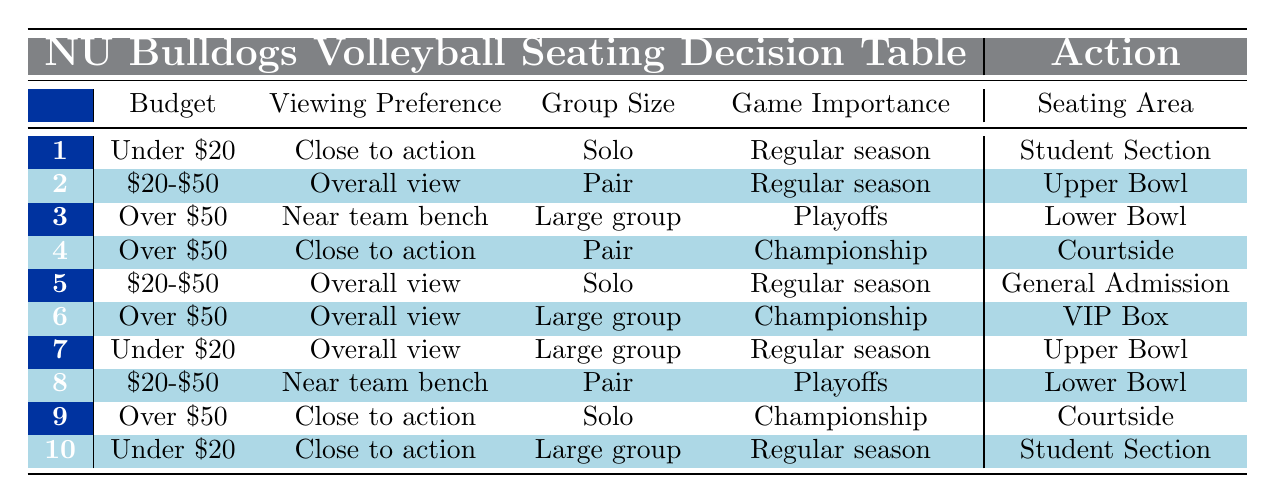What seating area is suggested for someone on a budget under $20 who prefers sitting close to the action for a regular season game? According to the table, for the conditions "Under $20," "Close to action," and "Regular season," the seating area suggested is "Student Section."
Answer: Student Section What is the recommended seating area if someone has a budget of $20 to $50, enjoys an overall view, is attending with a pair, and is going to a regular season game? The table states that for the conditions "$20-$50," "Overall view," "Pair," and "Regular season," the recommended seating area is "Upper Bowl."
Answer: Upper Bowl Is the "VIP Box" option available for large groups during championship games? Based on the table, the "VIP Box" option is available only under the conditions of "Over $50," "Overall view," "Large group," and "Championship." Therefore, yes, it is available.
Answer: Yes What seating area is recommended for a solo attendee with a budget of over $50 who wants to sit close to the action during a championship game? For "Over $50," "Close to action," "Solo," and "Championship," the table indicates the recommended seating area is "Courtside."
Answer: Courtside Can you identify the number of seating options available for individuals or pairs with a budget of $20 to $50 during playoff games? The table provides two relevant rules for this condition: one for "Overall view" which suggests "Upper Bowl" for a pair, and one for "Near team bench" which suggests "Lower Bowl" for a pair as well. This totals to three options that fit the requirement.
Answer: 2 If a large group wants to watch a regular season game and is on a budget of under $20, which seating area is available? For the conditions of "Under $20," "Overall view," "Large group," and "Regular season," the seating area listed in the table is "Upper Bowl."
Answer: Upper Bowl For an individual attending a playoff game and willing to spend over $50, where should they sit if they prefer an overall view? The table indicates that for "Over $50," "Overall view," "Solo," and "Playoffs," the suggested seating area is "General Admission."
Answer: General Admission What options are available for a duo wanting to sit near the team bench during a championship game with a budget of $20 to $50? According to the table, "Near team bench," "Pair," and "Championship" conditions lead to "Lower Bowl." Therefore, for the stated conditions, only one option is available.
Answer: 1 If a person is trying to decide between courtside and student section for a solo experience, based on the rules, which option would be better for a championship game? The table specifies that "Courtside" is for a solo experience during a championship game with a budget over $50, whereas the "Student Section" is only suitable for regular season games. Thus, for a championship game, "Courtside" is the better option.
Answer: Courtside 